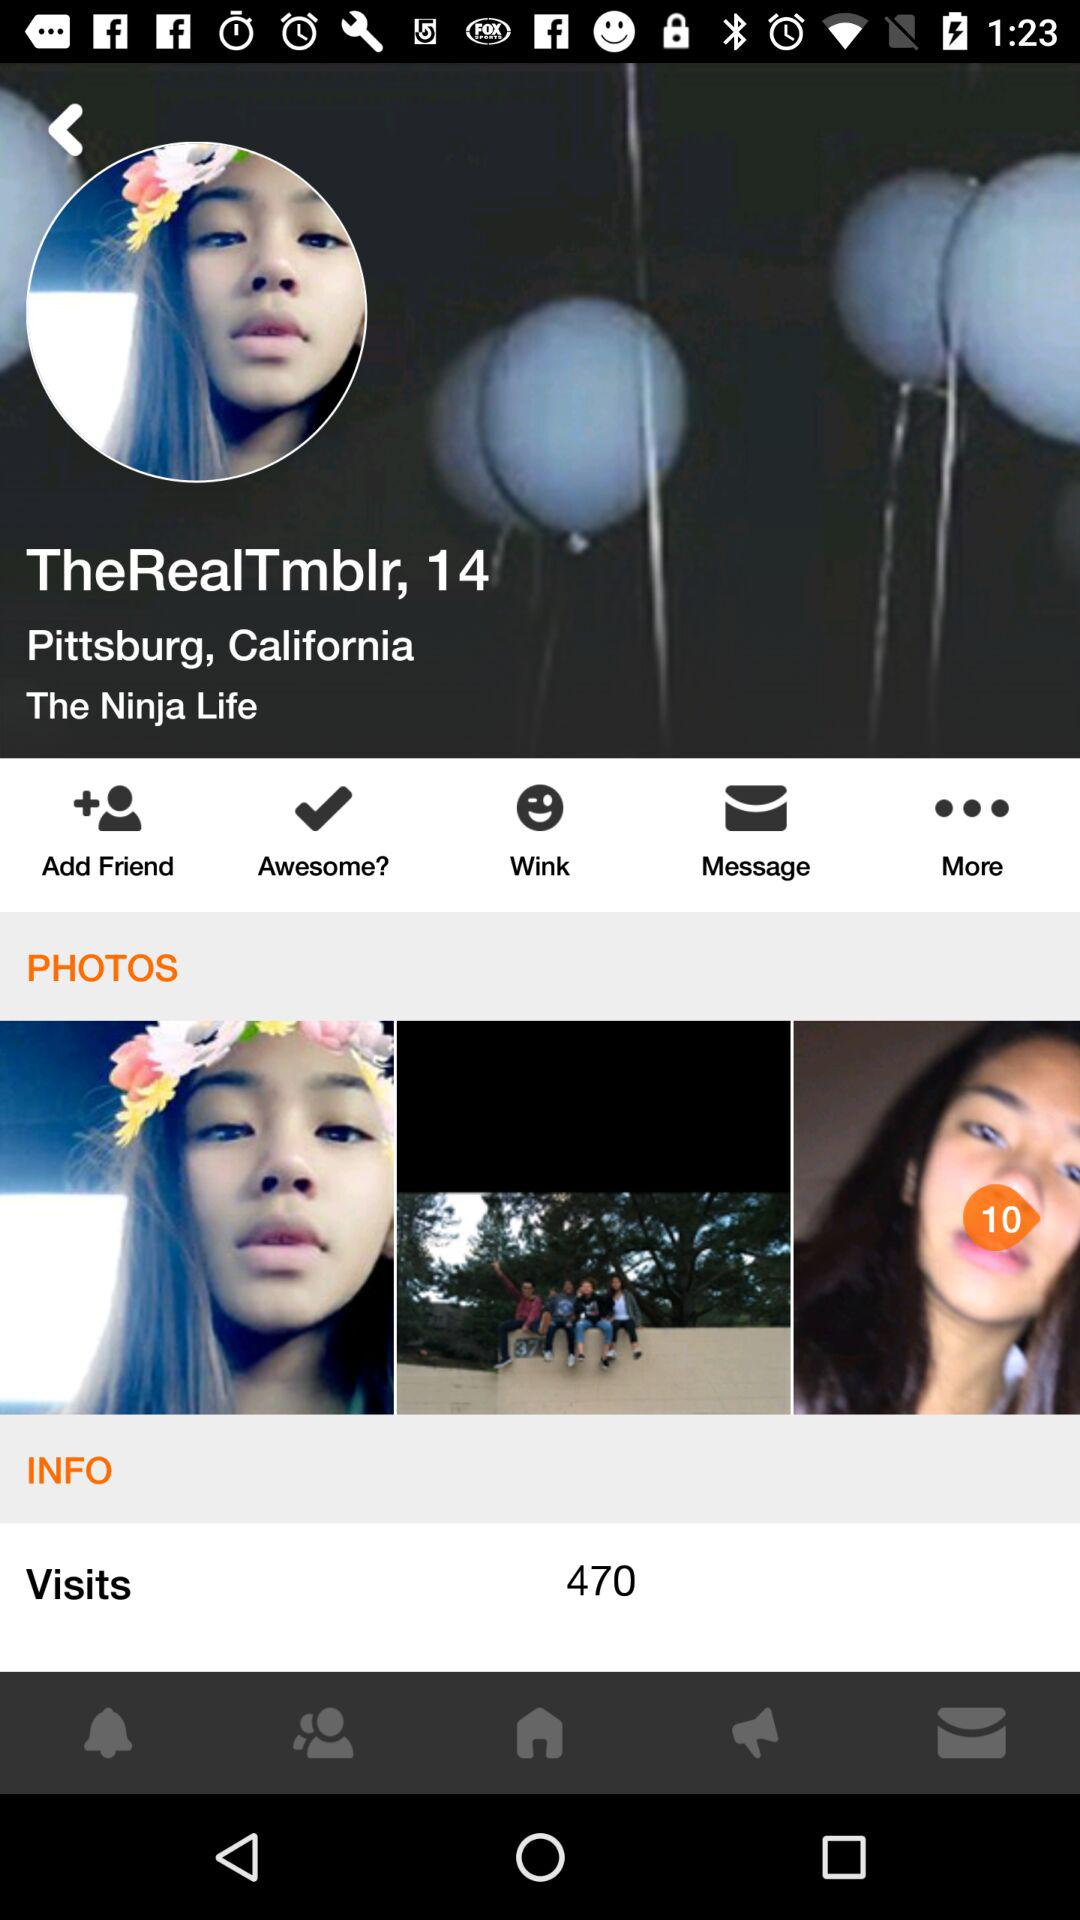What is the total number of photos the user has? The total number of photos the user has is 10. 